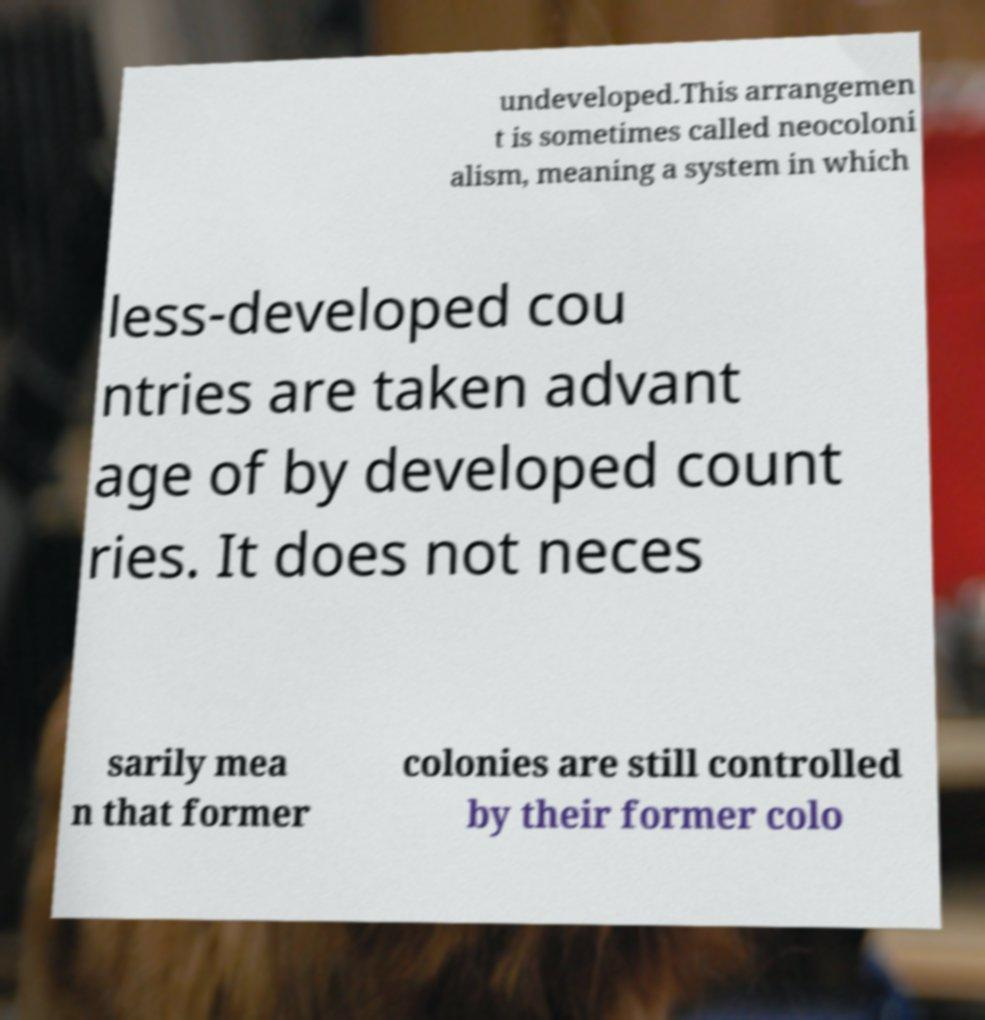I need the written content from this picture converted into text. Can you do that? undeveloped.This arrangemen t is sometimes called neocoloni alism, meaning a system in which less-developed cou ntries are taken advant age of by developed count ries. It does not neces sarily mea n that former colonies are still controlled by their former colo 